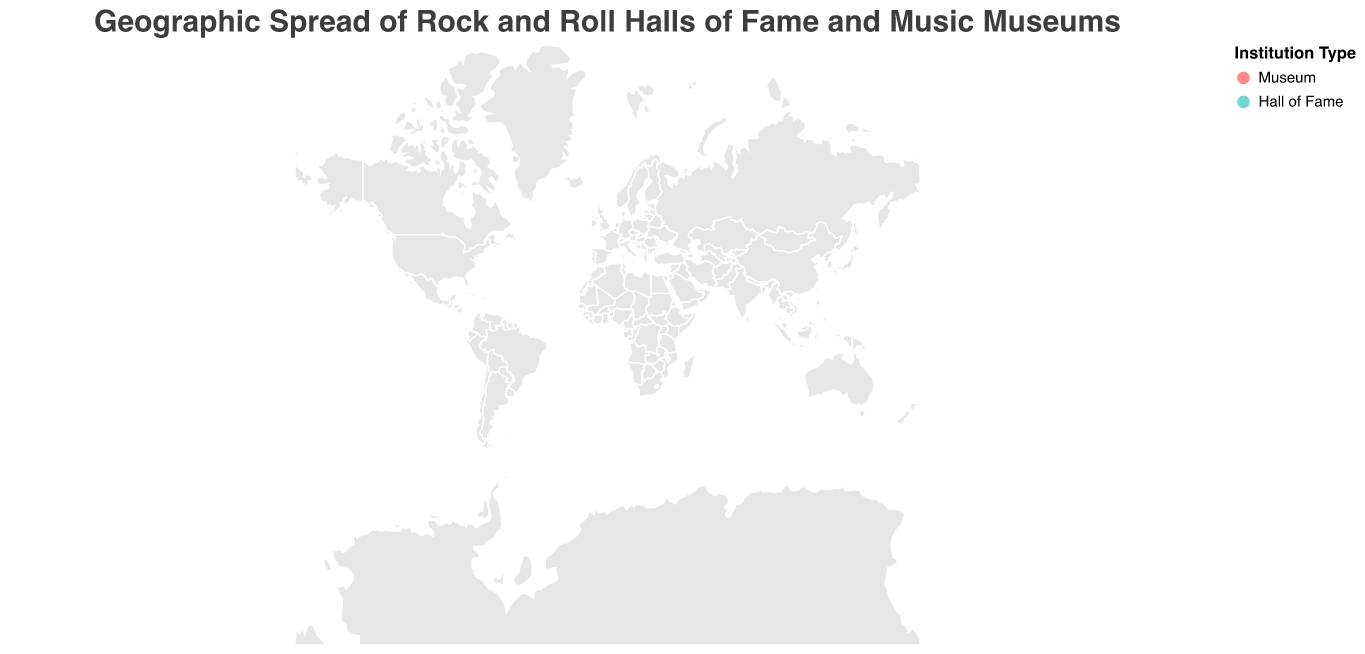How many rock and roll halls of fame are included in the figure? The title indicates that the plot is about the geographic spread of rock and roll halls of fame and music museums. By examining the legend, we see that "Hall of Fame" is represented by turquoise. There are only two turquoise circles on the map.
Answer: 2 What's the name of the most visited institution in the figure? To answer this, look at the size of the circles, which represents the number of visitors. The largest circle corresponds to the Country Music Hall of Fame and Museum.
Answer: Country Music Hall of Fame and Museum Among institutions established in 1997, which one has more visitors? Identify the establishments with the tooltip indicating they were established in 1997: American Jazz Museum and Musée de la Musique. Compare their visitor numbers, which are 50,000 and 150,000, respectively.
Answer: Musée de la Musique Which institution in the figure is the newest? Check the tooltip data for the "Year Established" and find the institution with the most recent year, which is 2016. The National Blues Museum was established in 2016.
Answer: National Blues Museum Compare the annual visitors of the Rock and Roll Hall of Fame and the GRAMMY Museum. Which one has more visitors and by how much? Look at the visitor data for the Rock and Roll Hall of Fame and the GRAMMY Museum. The Rock and Roll Hall of Fame has 500,000 visitors, and the GRAMMY Museum has 200,000 visitors. The difference is 500,000 - 200,000.
Answer: Rock and Roll Hall of Fame by 300,000 What's the average number of annual visitors for the music museums in Europe? Identify the European museums: British Music Experience, The Beatles Story, Glasgow Music Tour, and Musée de la Musique. Calculate their average by summing their visitors (100,000 + 300,000 + 40,000 + 150,000) and dividing by 4. The sum is 590,000, and the average is 590,000 / 4.
Answer: 147,500 Which institution type has a higher average number of annual visitors, museums or halls of fame? Sum the visitors for each type: Museums have 50,000 + 75,000 + 60,000 + 200,000 + 100,000 + 300,000 + 40,000 + 150,000 = 975,000. Halls of Fame have 500,000 + 1,200,000 = 1,700,000. Divide by the number of institutions of each type (8 for museums and 2 for halls of fame). The average for museums is 975,000 / 8 = 121,875, and for halls of fame, 1,700,000 / 2 = 850,000.
Answer: Halls of Fame What color represents music museums on the plot? Look at the legend, which indicates that "Museum" is represented by red circles.
Answer: red 